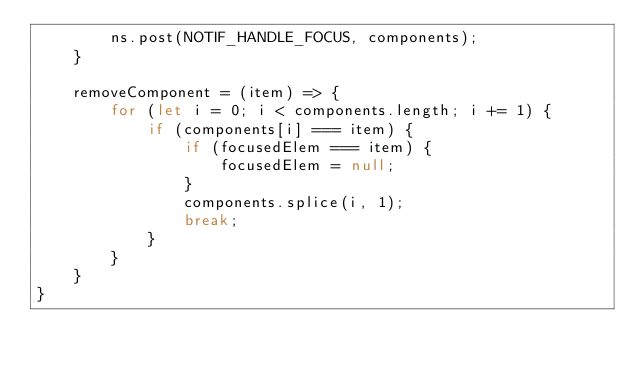Convert code to text. <code><loc_0><loc_0><loc_500><loc_500><_JavaScript_>        ns.post(NOTIF_HANDLE_FOCUS, components);
    }

    removeComponent = (item) => {
        for (let i = 0; i < components.length; i += 1) {
            if (components[i] === item) {
                if (focusedElem === item) {
                    focusedElem = null;
                }
                components.splice(i, 1);
                break;
            }
        }
    }
}
</code> 